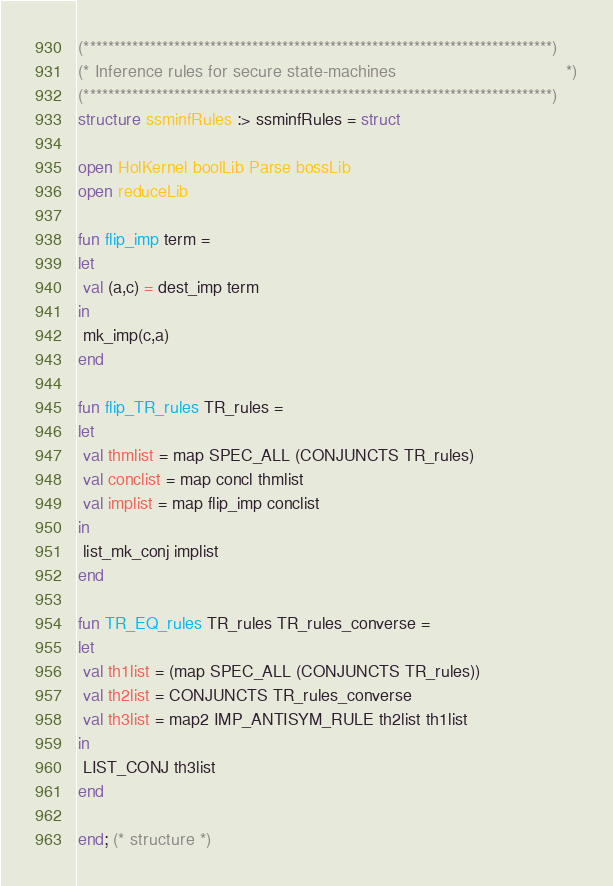<code> <loc_0><loc_0><loc_500><loc_500><_SML_>

(******************************************************************************)
(* Inference rules for secure state-machines                                  *)
(******************************************************************************)
structure ssminfRules :> ssminfRules = struct

open HolKernel boolLib Parse bossLib
open reduceLib

fun flip_imp term = 
let
 val (a,c) = dest_imp term
in
 mk_imp(c,a)
end

fun flip_TR_rules TR_rules =
let
 val thmlist = map SPEC_ALL (CONJUNCTS TR_rules)
 val conclist = map concl thmlist
 val implist = map flip_imp conclist
in
 list_mk_conj implist
end

fun TR_EQ_rules TR_rules TR_rules_converse =
let
 val th1list = (map SPEC_ALL (CONJUNCTS TR_rules))
 val th2list = CONJUNCTS TR_rules_converse
 val th3list = map2 IMP_ANTISYM_RULE th2list th1list
in
 LIST_CONJ th3list
end

end; (* structure *)</code> 